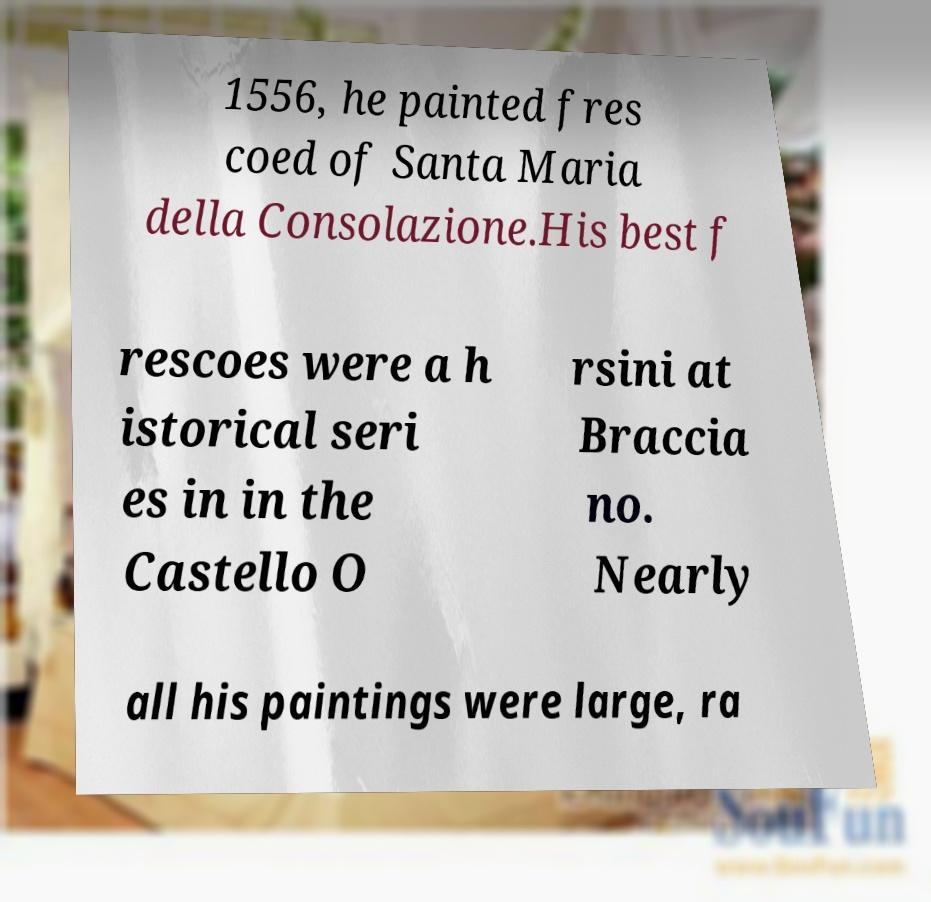Can you read and provide the text displayed in the image?This photo seems to have some interesting text. Can you extract and type it out for me? 1556, he painted fres coed of Santa Maria della Consolazione.His best f rescoes were a h istorical seri es in in the Castello O rsini at Braccia no. Nearly all his paintings were large, ra 